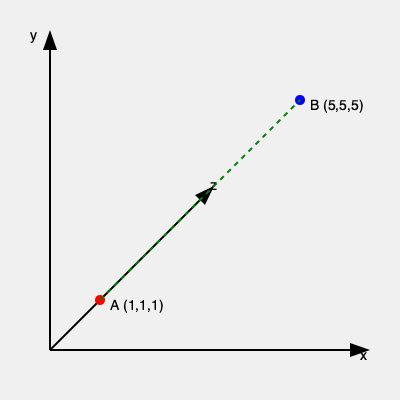In a 3D virtual reality environment, you need to navigate from point A (1,1,1) to point B (5,5,5) through a maze. Given that the shortest path is a straight line, what is the length of this path? To find the length of the shortest path in 3D space, we need to calculate the distance between two points using the 3D distance formula:

1. The 3D distance formula is derived from the Pythagorean theorem extended to three dimensions:
   $d = \sqrt{(x_2-x_1)^2 + (y_2-y_1)^2 + (z_2-z_1)^2}$

2. We have the coordinates:
   Point A: $(x_1, y_1, z_1) = (1, 1, 1)$
   Point B: $(x_2, y_2, z_2) = (5, 5, 5)$

3. Let's substitute these values into the formula:
   $d = \sqrt{(5-1)^2 + (5-1)^2 + (5-1)^2}$

4. Simplify the expressions inside the parentheses:
   $d = \sqrt{4^2 + 4^2 + 4^2}$

5. Calculate the squares:
   $d = \sqrt{16 + 16 + 16}$

6. Sum up the values under the square root:
   $d = \sqrt{48}$

7. Simplify the square root:
   $d = 4\sqrt{3}$

Therefore, the length of the shortest path from A to B is $4\sqrt{3}$ units.
Answer: $4\sqrt{3}$ units 